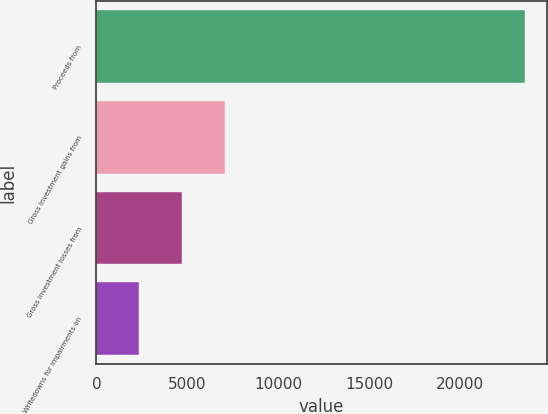Convert chart. <chart><loc_0><loc_0><loc_500><loc_500><bar_chart><fcel>Proceeds from<fcel>Gross investment gains from<fcel>Gross investment losses from<fcel>Writedowns for impairments on<nl><fcel>23573<fcel>7073.2<fcel>4716.08<fcel>2358.96<nl></chart> 